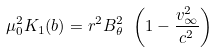<formula> <loc_0><loc_0><loc_500><loc_500>\mu _ { 0 } ^ { 2 } K _ { 1 } ( b ) = r ^ { 2 } B _ { \theta } ^ { 2 } \ \left ( 1 - \frac { v _ { \infty } ^ { 2 } } { c ^ { 2 } } \right )</formula> 